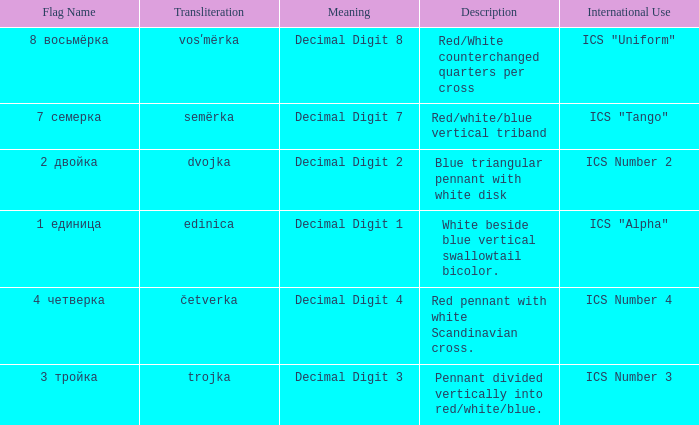Parse the table in full. {'header': ['Flag Name', 'Transliteration', 'Meaning', 'Description', 'International Use'], 'rows': [['8 восьмёрка', 'vosʹmërka', 'Decimal Digit 8', 'Red/White counterchanged quarters per cross', 'ICS "Uniform"'], ['7 семерка', 'semërka', 'Decimal Digit 7', 'Red/white/blue vertical triband', 'ICS "Tango"'], ['2 двойка', 'dvojka', 'Decimal Digit 2', 'Blue triangular pennant with white disk', 'ICS Number 2'], ['1 единица', 'edinica', 'Decimal Digit 1', 'White beside blue vertical swallowtail bicolor.', 'ICS "Alpha"'], ['4 четверка', 'četverka', 'Decimal Digit 4', 'Red pennant with white Scandinavian cross.', 'ICS Number 4'], ['3 тройка', 'trojka', 'Decimal Digit 3', 'Pennant divided vertically into red/white/blue.', 'ICS Number 3']]} How many different descriptions are there for the flag that means decimal digit 2? 1.0. 